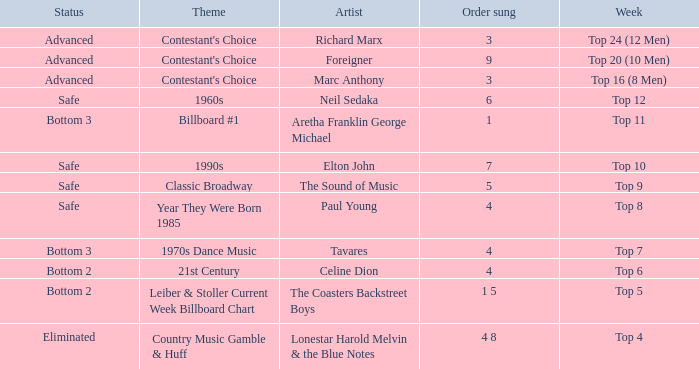What artist's song was performed in the week with theme of Billboard #1? Aretha Franklin George Michael. 